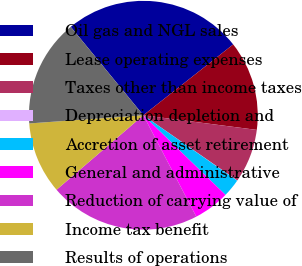<chart> <loc_0><loc_0><loc_500><loc_500><pie_chart><fcel>Oil gas and NGL sales<fcel>Lease operating expenses<fcel>Taxes other than income taxes<fcel>Depreciation depletion and<fcel>Accretion of asset retirement<fcel>General and administrative<fcel>Reduction of carrying value of<fcel>Income tax benefit<fcel>Results of operations<nl><fcel>25.32%<fcel>12.67%<fcel>7.62%<fcel>0.03%<fcel>2.56%<fcel>5.09%<fcel>21.37%<fcel>10.15%<fcel>15.2%<nl></chart> 